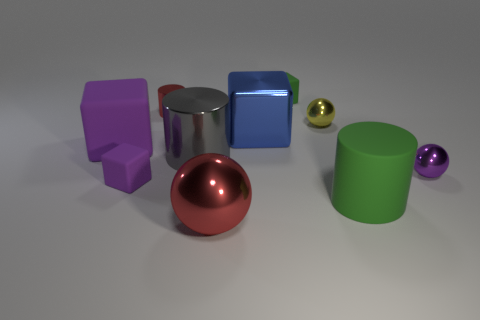Subtract all blue cylinders. How many purple blocks are left? 2 Subtract 1 cylinders. How many cylinders are left? 2 Subtract all tiny balls. How many balls are left? 1 Subtract all blue blocks. How many blocks are left? 3 Subtract all cyan cylinders. Subtract all red blocks. How many cylinders are left? 3 Subtract 1 purple blocks. How many objects are left? 9 Subtract all cylinders. How many objects are left? 7 Subtract all red things. Subtract all big green rubber things. How many objects are left? 7 Add 5 big metal objects. How many big metal objects are left? 8 Add 2 large blue blocks. How many large blue blocks exist? 3 